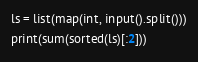Convert code to text. <code><loc_0><loc_0><loc_500><loc_500><_Python_>ls = list(map(int, input().split()))
print(sum(sorted(ls)[:2]))</code> 